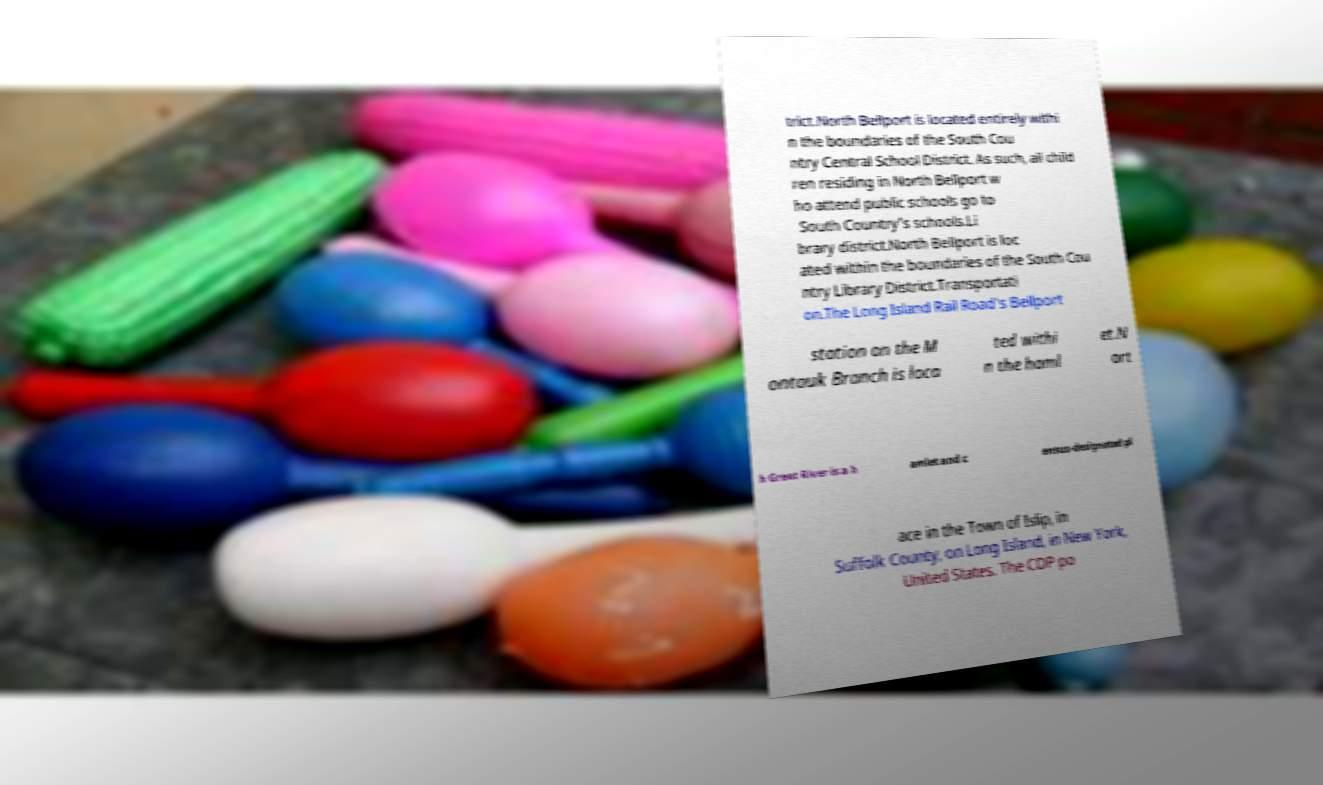There's text embedded in this image that I need extracted. Can you transcribe it verbatim? trict.North Bellport is located entirely withi n the boundaries of the South Cou ntry Central School District. As such, all child ren residing in North Bellport w ho attend public schools go to South Country's schools.Li brary district.North Bellport is loc ated within the boundaries of the South Cou ntry Library District.Transportati on.The Long Island Rail Road's Bellport station on the M ontauk Branch is loca ted withi n the haml et.N ort h Great River is a h amlet and c ensus-designated pl ace in the Town of Islip, in Suffolk County, on Long Island, in New York, United States. The CDP po 